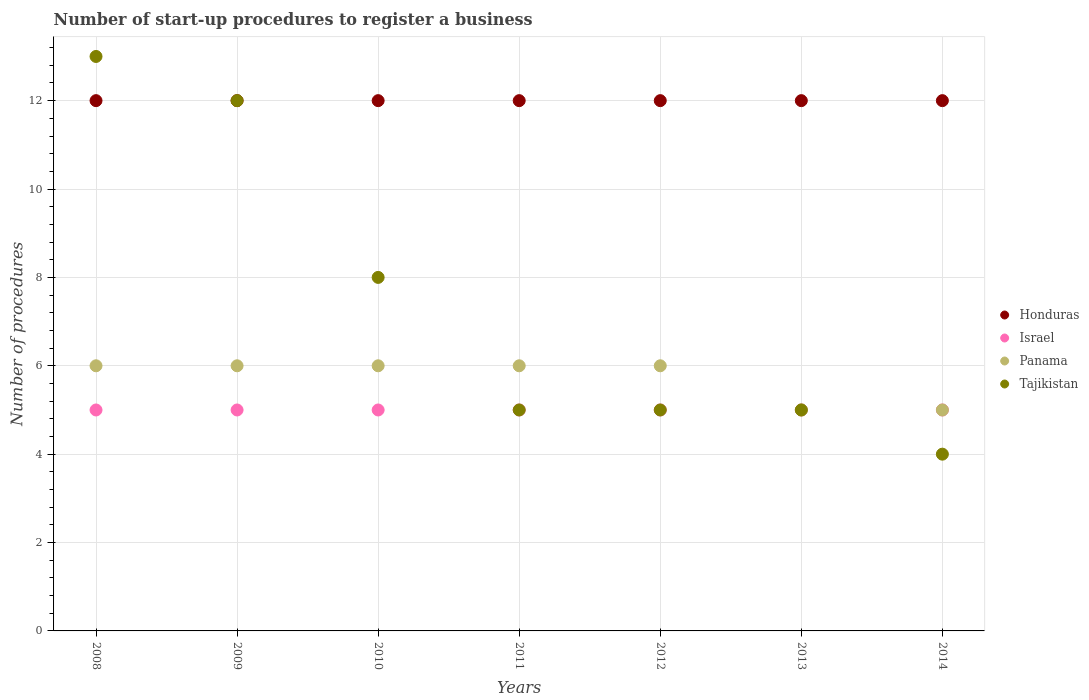Is the number of dotlines equal to the number of legend labels?
Provide a short and direct response. Yes. What is the number of procedures required to register a business in Israel in 2012?
Your answer should be very brief. 5. Across all years, what is the maximum number of procedures required to register a business in Panama?
Ensure brevity in your answer.  6. Across all years, what is the minimum number of procedures required to register a business in Panama?
Your response must be concise. 5. In which year was the number of procedures required to register a business in Tajikistan maximum?
Provide a succinct answer. 2008. In which year was the number of procedures required to register a business in Tajikistan minimum?
Ensure brevity in your answer.  2014. What is the total number of procedures required to register a business in Israel in the graph?
Ensure brevity in your answer.  35. What is the difference between the number of procedures required to register a business in Tajikistan in 2011 and the number of procedures required to register a business in Israel in 2013?
Offer a terse response. 0. What is the average number of procedures required to register a business in Tajikistan per year?
Give a very brief answer. 7.43. In the year 2008, what is the difference between the number of procedures required to register a business in Honduras and number of procedures required to register a business in Israel?
Keep it short and to the point. 7. In how many years, is the number of procedures required to register a business in Tajikistan greater than 12.4?
Your response must be concise. 1. What is the ratio of the number of procedures required to register a business in Panama in 2008 to that in 2012?
Your answer should be compact. 1. Is the number of procedures required to register a business in Panama in 2010 less than that in 2011?
Ensure brevity in your answer.  No. Is the difference between the number of procedures required to register a business in Honduras in 2013 and 2014 greater than the difference between the number of procedures required to register a business in Israel in 2013 and 2014?
Your answer should be very brief. No. What is the difference between the highest and the lowest number of procedures required to register a business in Tajikistan?
Give a very brief answer. 9. Is the sum of the number of procedures required to register a business in Panama in 2012 and 2014 greater than the maximum number of procedures required to register a business in Tajikistan across all years?
Keep it short and to the point. No. Is it the case that in every year, the sum of the number of procedures required to register a business in Tajikistan and number of procedures required to register a business in Panama  is greater than the sum of number of procedures required to register a business in Honduras and number of procedures required to register a business in Israel?
Your answer should be very brief. No. Does the number of procedures required to register a business in Honduras monotonically increase over the years?
Offer a very short reply. No. Is the number of procedures required to register a business in Panama strictly greater than the number of procedures required to register a business in Israel over the years?
Ensure brevity in your answer.  No. How many dotlines are there?
Make the answer very short. 4. What is the difference between two consecutive major ticks on the Y-axis?
Ensure brevity in your answer.  2. Are the values on the major ticks of Y-axis written in scientific E-notation?
Offer a very short reply. No. Does the graph contain grids?
Offer a terse response. Yes. How are the legend labels stacked?
Provide a short and direct response. Vertical. What is the title of the graph?
Provide a succinct answer. Number of start-up procedures to register a business. Does "World" appear as one of the legend labels in the graph?
Your response must be concise. No. What is the label or title of the Y-axis?
Offer a terse response. Number of procedures. What is the Number of procedures of Honduras in 2008?
Give a very brief answer. 12. What is the Number of procedures of Israel in 2008?
Provide a short and direct response. 5. What is the Number of procedures of Panama in 2008?
Offer a terse response. 6. What is the Number of procedures in Tajikistan in 2008?
Give a very brief answer. 13. What is the Number of procedures of Israel in 2009?
Offer a terse response. 5. What is the Number of procedures of Panama in 2009?
Give a very brief answer. 6. What is the Number of procedures of Panama in 2010?
Your answer should be very brief. 6. What is the Number of procedures of Honduras in 2011?
Ensure brevity in your answer.  12. What is the Number of procedures of Tajikistan in 2011?
Keep it short and to the point. 5. What is the Number of procedures of Honduras in 2012?
Make the answer very short. 12. What is the Number of procedures in Israel in 2012?
Provide a succinct answer. 5. What is the Number of procedures of Panama in 2012?
Provide a short and direct response. 6. What is the Number of procedures in Tajikistan in 2012?
Provide a succinct answer. 5. What is the Number of procedures of Honduras in 2013?
Ensure brevity in your answer.  12. What is the Number of procedures of Panama in 2013?
Your response must be concise. 5. What is the Number of procedures in Honduras in 2014?
Offer a terse response. 12. What is the Number of procedures in Israel in 2014?
Offer a very short reply. 5. What is the Number of procedures of Panama in 2014?
Ensure brevity in your answer.  5. Across all years, what is the maximum Number of procedures in Israel?
Make the answer very short. 5. Across all years, what is the maximum Number of procedures of Panama?
Your response must be concise. 6. Across all years, what is the maximum Number of procedures in Tajikistan?
Ensure brevity in your answer.  13. Across all years, what is the minimum Number of procedures of Israel?
Your answer should be very brief. 5. What is the total Number of procedures of Honduras in the graph?
Your answer should be compact. 84. What is the total Number of procedures in Israel in the graph?
Keep it short and to the point. 35. What is the difference between the Number of procedures of Panama in 2008 and that in 2009?
Give a very brief answer. 0. What is the difference between the Number of procedures of Panama in 2008 and that in 2010?
Offer a very short reply. 0. What is the difference between the Number of procedures in Panama in 2008 and that in 2011?
Provide a short and direct response. 0. What is the difference between the Number of procedures of Honduras in 2008 and that in 2012?
Provide a succinct answer. 0. What is the difference between the Number of procedures of Panama in 2008 and that in 2012?
Ensure brevity in your answer.  0. What is the difference between the Number of procedures of Tajikistan in 2008 and that in 2012?
Ensure brevity in your answer.  8. What is the difference between the Number of procedures of Israel in 2008 and that in 2013?
Ensure brevity in your answer.  0. What is the difference between the Number of procedures of Panama in 2008 and that in 2013?
Your response must be concise. 1. What is the difference between the Number of procedures in Tajikistan in 2008 and that in 2013?
Provide a short and direct response. 8. What is the difference between the Number of procedures of Honduras in 2008 and that in 2014?
Give a very brief answer. 0. What is the difference between the Number of procedures of Tajikistan in 2008 and that in 2014?
Provide a succinct answer. 9. What is the difference between the Number of procedures in Honduras in 2009 and that in 2010?
Offer a terse response. 0. What is the difference between the Number of procedures of Israel in 2009 and that in 2010?
Your response must be concise. 0. What is the difference between the Number of procedures of Tajikistan in 2009 and that in 2010?
Your response must be concise. 4. What is the difference between the Number of procedures of Honduras in 2009 and that in 2011?
Ensure brevity in your answer.  0. What is the difference between the Number of procedures in Honduras in 2009 and that in 2012?
Provide a short and direct response. 0. What is the difference between the Number of procedures in Israel in 2009 and that in 2012?
Offer a very short reply. 0. What is the difference between the Number of procedures in Panama in 2009 and that in 2012?
Give a very brief answer. 0. What is the difference between the Number of procedures of Honduras in 2009 and that in 2014?
Provide a short and direct response. 0. What is the difference between the Number of procedures of Israel in 2009 and that in 2014?
Offer a very short reply. 0. What is the difference between the Number of procedures in Tajikistan in 2009 and that in 2014?
Make the answer very short. 8. What is the difference between the Number of procedures of Honduras in 2010 and that in 2011?
Give a very brief answer. 0. What is the difference between the Number of procedures of Panama in 2010 and that in 2011?
Your response must be concise. 0. What is the difference between the Number of procedures in Israel in 2010 and that in 2012?
Your response must be concise. 0. What is the difference between the Number of procedures in Tajikistan in 2010 and that in 2013?
Give a very brief answer. 3. What is the difference between the Number of procedures in Honduras in 2010 and that in 2014?
Your answer should be compact. 0. What is the difference between the Number of procedures of Israel in 2010 and that in 2014?
Provide a succinct answer. 0. What is the difference between the Number of procedures of Panama in 2010 and that in 2014?
Give a very brief answer. 1. What is the difference between the Number of procedures in Tajikistan in 2010 and that in 2014?
Offer a very short reply. 4. What is the difference between the Number of procedures in Israel in 2011 and that in 2012?
Make the answer very short. 0. What is the difference between the Number of procedures in Honduras in 2011 and that in 2013?
Offer a terse response. 0. What is the difference between the Number of procedures in Israel in 2011 and that in 2013?
Offer a very short reply. 0. What is the difference between the Number of procedures of Panama in 2011 and that in 2013?
Make the answer very short. 1. What is the difference between the Number of procedures in Tajikistan in 2011 and that in 2014?
Your answer should be very brief. 1. What is the difference between the Number of procedures in Honduras in 2012 and that in 2014?
Give a very brief answer. 0. What is the difference between the Number of procedures in Israel in 2012 and that in 2014?
Offer a terse response. 0. What is the difference between the Number of procedures of Panama in 2012 and that in 2014?
Your answer should be compact. 1. What is the difference between the Number of procedures of Honduras in 2013 and that in 2014?
Your answer should be compact. 0. What is the difference between the Number of procedures of Tajikistan in 2013 and that in 2014?
Give a very brief answer. 1. What is the difference between the Number of procedures of Honduras in 2008 and the Number of procedures of Panama in 2009?
Make the answer very short. 6. What is the difference between the Number of procedures in Honduras in 2008 and the Number of procedures in Tajikistan in 2009?
Keep it short and to the point. 0. What is the difference between the Number of procedures in Israel in 2008 and the Number of procedures in Panama in 2009?
Ensure brevity in your answer.  -1. What is the difference between the Number of procedures in Israel in 2008 and the Number of procedures in Tajikistan in 2009?
Make the answer very short. -7. What is the difference between the Number of procedures in Panama in 2008 and the Number of procedures in Tajikistan in 2009?
Offer a very short reply. -6. What is the difference between the Number of procedures in Honduras in 2008 and the Number of procedures in Tajikistan in 2010?
Make the answer very short. 4. What is the difference between the Number of procedures of Israel in 2008 and the Number of procedures of Panama in 2010?
Your answer should be very brief. -1. What is the difference between the Number of procedures in Israel in 2008 and the Number of procedures in Tajikistan in 2010?
Your answer should be compact. -3. What is the difference between the Number of procedures in Panama in 2008 and the Number of procedures in Tajikistan in 2010?
Provide a short and direct response. -2. What is the difference between the Number of procedures of Honduras in 2008 and the Number of procedures of Israel in 2011?
Give a very brief answer. 7. What is the difference between the Number of procedures of Honduras in 2008 and the Number of procedures of Panama in 2011?
Your answer should be very brief. 6. What is the difference between the Number of procedures in Israel in 2008 and the Number of procedures in Panama in 2011?
Make the answer very short. -1. What is the difference between the Number of procedures in Israel in 2008 and the Number of procedures in Tajikistan in 2011?
Provide a short and direct response. 0. What is the difference between the Number of procedures of Panama in 2008 and the Number of procedures of Tajikistan in 2011?
Your response must be concise. 1. What is the difference between the Number of procedures of Honduras in 2008 and the Number of procedures of Israel in 2012?
Offer a terse response. 7. What is the difference between the Number of procedures of Honduras in 2008 and the Number of procedures of Panama in 2012?
Keep it short and to the point. 6. What is the difference between the Number of procedures in Honduras in 2008 and the Number of procedures in Panama in 2013?
Keep it short and to the point. 7. What is the difference between the Number of procedures in Honduras in 2008 and the Number of procedures in Tajikistan in 2013?
Your response must be concise. 7. What is the difference between the Number of procedures in Israel in 2008 and the Number of procedures in Panama in 2013?
Your response must be concise. 0. What is the difference between the Number of procedures of Honduras in 2008 and the Number of procedures of Panama in 2014?
Ensure brevity in your answer.  7. What is the difference between the Number of procedures of Panama in 2008 and the Number of procedures of Tajikistan in 2014?
Offer a terse response. 2. What is the difference between the Number of procedures in Honduras in 2009 and the Number of procedures in Panama in 2010?
Offer a very short reply. 6. What is the difference between the Number of procedures in Israel in 2009 and the Number of procedures in Panama in 2010?
Make the answer very short. -1. What is the difference between the Number of procedures in Israel in 2009 and the Number of procedures in Tajikistan in 2010?
Offer a terse response. -3. What is the difference between the Number of procedures in Panama in 2009 and the Number of procedures in Tajikistan in 2010?
Keep it short and to the point. -2. What is the difference between the Number of procedures in Honduras in 2009 and the Number of procedures in Israel in 2011?
Provide a succinct answer. 7. What is the difference between the Number of procedures in Honduras in 2009 and the Number of procedures in Panama in 2011?
Give a very brief answer. 6. What is the difference between the Number of procedures in Honduras in 2009 and the Number of procedures in Tajikistan in 2011?
Provide a short and direct response. 7. What is the difference between the Number of procedures in Israel in 2009 and the Number of procedures in Tajikistan in 2011?
Offer a terse response. 0. What is the difference between the Number of procedures in Israel in 2009 and the Number of procedures in Tajikistan in 2012?
Provide a succinct answer. 0. What is the difference between the Number of procedures of Israel in 2009 and the Number of procedures of Panama in 2013?
Provide a short and direct response. 0. What is the difference between the Number of procedures in Israel in 2009 and the Number of procedures in Tajikistan in 2013?
Offer a terse response. 0. What is the difference between the Number of procedures of Panama in 2009 and the Number of procedures of Tajikistan in 2013?
Give a very brief answer. 1. What is the difference between the Number of procedures in Honduras in 2009 and the Number of procedures in Panama in 2014?
Offer a very short reply. 7. What is the difference between the Number of procedures of Honduras in 2009 and the Number of procedures of Tajikistan in 2014?
Offer a terse response. 8. What is the difference between the Number of procedures of Israel in 2009 and the Number of procedures of Tajikistan in 2014?
Ensure brevity in your answer.  1. What is the difference between the Number of procedures of Honduras in 2010 and the Number of procedures of Israel in 2011?
Offer a very short reply. 7. What is the difference between the Number of procedures of Israel in 2010 and the Number of procedures of Tajikistan in 2011?
Your answer should be very brief. 0. What is the difference between the Number of procedures in Honduras in 2010 and the Number of procedures in Tajikistan in 2012?
Offer a very short reply. 7. What is the difference between the Number of procedures in Israel in 2010 and the Number of procedures in Tajikistan in 2012?
Offer a terse response. 0. What is the difference between the Number of procedures in Honduras in 2010 and the Number of procedures in Panama in 2013?
Provide a short and direct response. 7. What is the difference between the Number of procedures in Honduras in 2010 and the Number of procedures in Tajikistan in 2013?
Keep it short and to the point. 7. What is the difference between the Number of procedures of Israel in 2010 and the Number of procedures of Panama in 2013?
Your response must be concise. 0. What is the difference between the Number of procedures in Honduras in 2010 and the Number of procedures in Israel in 2014?
Give a very brief answer. 7. What is the difference between the Number of procedures in Panama in 2010 and the Number of procedures in Tajikistan in 2014?
Provide a short and direct response. 2. What is the difference between the Number of procedures of Honduras in 2011 and the Number of procedures of Israel in 2012?
Offer a very short reply. 7. What is the difference between the Number of procedures of Israel in 2011 and the Number of procedures of Panama in 2012?
Offer a terse response. -1. What is the difference between the Number of procedures in Honduras in 2011 and the Number of procedures in Israel in 2013?
Provide a short and direct response. 7. What is the difference between the Number of procedures in Honduras in 2011 and the Number of procedures in Panama in 2013?
Your answer should be very brief. 7. What is the difference between the Number of procedures of Panama in 2011 and the Number of procedures of Tajikistan in 2013?
Your answer should be very brief. 1. What is the difference between the Number of procedures of Honduras in 2011 and the Number of procedures of Panama in 2014?
Keep it short and to the point. 7. What is the difference between the Number of procedures in Panama in 2011 and the Number of procedures in Tajikistan in 2014?
Your response must be concise. 2. What is the difference between the Number of procedures of Honduras in 2012 and the Number of procedures of Israel in 2013?
Provide a succinct answer. 7. What is the difference between the Number of procedures in Honduras in 2012 and the Number of procedures in Panama in 2013?
Your response must be concise. 7. What is the difference between the Number of procedures in Honduras in 2012 and the Number of procedures in Tajikistan in 2013?
Make the answer very short. 7. What is the difference between the Number of procedures of Israel in 2012 and the Number of procedures of Panama in 2013?
Your response must be concise. 0. What is the difference between the Number of procedures of Panama in 2012 and the Number of procedures of Tajikistan in 2013?
Provide a short and direct response. 1. What is the difference between the Number of procedures in Honduras in 2012 and the Number of procedures in Israel in 2014?
Your answer should be very brief. 7. What is the difference between the Number of procedures in Honduras in 2012 and the Number of procedures in Tajikistan in 2014?
Your answer should be compact. 8. What is the difference between the Number of procedures of Panama in 2012 and the Number of procedures of Tajikistan in 2014?
Give a very brief answer. 2. What is the difference between the Number of procedures of Israel in 2013 and the Number of procedures of Panama in 2014?
Provide a succinct answer. 0. What is the difference between the Number of procedures of Panama in 2013 and the Number of procedures of Tajikistan in 2014?
Give a very brief answer. 1. What is the average Number of procedures in Honduras per year?
Provide a succinct answer. 12. What is the average Number of procedures in Israel per year?
Your response must be concise. 5. What is the average Number of procedures in Panama per year?
Provide a succinct answer. 5.71. What is the average Number of procedures in Tajikistan per year?
Your answer should be compact. 7.43. In the year 2008, what is the difference between the Number of procedures in Honduras and Number of procedures in Israel?
Make the answer very short. 7. In the year 2008, what is the difference between the Number of procedures of Honduras and Number of procedures of Panama?
Make the answer very short. 6. In the year 2008, what is the difference between the Number of procedures of Israel and Number of procedures of Tajikistan?
Provide a short and direct response. -8. In the year 2008, what is the difference between the Number of procedures of Panama and Number of procedures of Tajikistan?
Your response must be concise. -7. In the year 2009, what is the difference between the Number of procedures of Honduras and Number of procedures of Israel?
Give a very brief answer. 7. In the year 2009, what is the difference between the Number of procedures in Honduras and Number of procedures in Panama?
Keep it short and to the point. 6. In the year 2009, what is the difference between the Number of procedures of Honduras and Number of procedures of Tajikistan?
Ensure brevity in your answer.  0. In the year 2010, what is the difference between the Number of procedures of Honduras and Number of procedures of Tajikistan?
Offer a very short reply. 4. In the year 2011, what is the difference between the Number of procedures in Honduras and Number of procedures in Israel?
Your response must be concise. 7. In the year 2011, what is the difference between the Number of procedures in Panama and Number of procedures in Tajikistan?
Give a very brief answer. 1. In the year 2012, what is the difference between the Number of procedures in Honduras and Number of procedures in Panama?
Make the answer very short. 6. In the year 2012, what is the difference between the Number of procedures in Honduras and Number of procedures in Tajikistan?
Provide a succinct answer. 7. In the year 2012, what is the difference between the Number of procedures of Israel and Number of procedures of Panama?
Provide a succinct answer. -1. In the year 2013, what is the difference between the Number of procedures in Honduras and Number of procedures in Tajikistan?
Ensure brevity in your answer.  7. In the year 2013, what is the difference between the Number of procedures in Panama and Number of procedures in Tajikistan?
Give a very brief answer. 0. In the year 2014, what is the difference between the Number of procedures in Honduras and Number of procedures in Tajikistan?
Your answer should be compact. 8. In the year 2014, what is the difference between the Number of procedures in Israel and Number of procedures in Tajikistan?
Your answer should be very brief. 1. In the year 2014, what is the difference between the Number of procedures in Panama and Number of procedures in Tajikistan?
Your response must be concise. 1. What is the ratio of the Number of procedures of Honduras in 2008 to that in 2009?
Your response must be concise. 1. What is the ratio of the Number of procedures of Panama in 2008 to that in 2009?
Ensure brevity in your answer.  1. What is the ratio of the Number of procedures of Honduras in 2008 to that in 2010?
Give a very brief answer. 1. What is the ratio of the Number of procedures in Israel in 2008 to that in 2010?
Offer a terse response. 1. What is the ratio of the Number of procedures in Panama in 2008 to that in 2010?
Offer a terse response. 1. What is the ratio of the Number of procedures of Tajikistan in 2008 to that in 2010?
Your response must be concise. 1.62. What is the ratio of the Number of procedures of Honduras in 2008 to that in 2011?
Offer a terse response. 1. What is the ratio of the Number of procedures of Panama in 2008 to that in 2011?
Your response must be concise. 1. What is the ratio of the Number of procedures in Tajikistan in 2008 to that in 2011?
Provide a short and direct response. 2.6. What is the ratio of the Number of procedures of Israel in 2008 to that in 2012?
Offer a very short reply. 1. What is the ratio of the Number of procedures in Israel in 2008 to that in 2013?
Your response must be concise. 1. What is the ratio of the Number of procedures of Panama in 2008 to that in 2013?
Keep it short and to the point. 1.2. What is the ratio of the Number of procedures of Tajikistan in 2008 to that in 2013?
Offer a terse response. 2.6. What is the ratio of the Number of procedures of Israel in 2008 to that in 2014?
Offer a terse response. 1. What is the ratio of the Number of procedures of Panama in 2008 to that in 2014?
Keep it short and to the point. 1.2. What is the ratio of the Number of procedures in Israel in 2009 to that in 2011?
Provide a succinct answer. 1. What is the ratio of the Number of procedures of Tajikistan in 2009 to that in 2011?
Offer a very short reply. 2.4. What is the ratio of the Number of procedures in Tajikistan in 2009 to that in 2012?
Make the answer very short. 2.4. What is the ratio of the Number of procedures in Honduras in 2009 to that in 2013?
Offer a very short reply. 1. What is the ratio of the Number of procedures in Panama in 2009 to that in 2013?
Offer a very short reply. 1.2. What is the ratio of the Number of procedures in Tajikistan in 2009 to that in 2013?
Make the answer very short. 2.4. What is the ratio of the Number of procedures of Honduras in 2009 to that in 2014?
Provide a short and direct response. 1. What is the ratio of the Number of procedures of Panama in 2009 to that in 2014?
Make the answer very short. 1.2. What is the ratio of the Number of procedures of Tajikistan in 2010 to that in 2011?
Offer a very short reply. 1.6. What is the ratio of the Number of procedures of Honduras in 2010 to that in 2012?
Make the answer very short. 1. What is the ratio of the Number of procedures in Israel in 2010 to that in 2012?
Ensure brevity in your answer.  1. What is the ratio of the Number of procedures of Panama in 2010 to that in 2012?
Give a very brief answer. 1. What is the ratio of the Number of procedures of Tajikistan in 2010 to that in 2012?
Provide a short and direct response. 1.6. What is the ratio of the Number of procedures in Honduras in 2010 to that in 2013?
Make the answer very short. 1. What is the ratio of the Number of procedures of Israel in 2010 to that in 2013?
Ensure brevity in your answer.  1. What is the ratio of the Number of procedures in Panama in 2010 to that in 2013?
Make the answer very short. 1.2. What is the ratio of the Number of procedures in Tajikistan in 2010 to that in 2013?
Your answer should be very brief. 1.6. What is the ratio of the Number of procedures of Panama in 2011 to that in 2012?
Your answer should be very brief. 1. What is the ratio of the Number of procedures of Tajikistan in 2011 to that in 2012?
Your response must be concise. 1. What is the ratio of the Number of procedures of Tajikistan in 2011 to that in 2013?
Your response must be concise. 1. What is the ratio of the Number of procedures of Honduras in 2011 to that in 2014?
Keep it short and to the point. 1. What is the ratio of the Number of procedures of Panama in 2011 to that in 2014?
Offer a very short reply. 1.2. What is the ratio of the Number of procedures of Tajikistan in 2011 to that in 2014?
Your answer should be compact. 1.25. What is the ratio of the Number of procedures of Israel in 2012 to that in 2013?
Keep it short and to the point. 1. What is the ratio of the Number of procedures of Israel in 2012 to that in 2014?
Keep it short and to the point. 1. What is the ratio of the Number of procedures in Panama in 2012 to that in 2014?
Your response must be concise. 1.2. What is the ratio of the Number of procedures of Tajikistan in 2012 to that in 2014?
Keep it short and to the point. 1.25. What is the ratio of the Number of procedures in Honduras in 2013 to that in 2014?
Offer a very short reply. 1. What is the ratio of the Number of procedures in Israel in 2013 to that in 2014?
Offer a very short reply. 1. What is the difference between the highest and the second highest Number of procedures of Israel?
Your answer should be very brief. 0. What is the difference between the highest and the second highest Number of procedures in Tajikistan?
Your response must be concise. 1. What is the difference between the highest and the lowest Number of procedures of Honduras?
Offer a very short reply. 0. What is the difference between the highest and the lowest Number of procedures in Israel?
Keep it short and to the point. 0. What is the difference between the highest and the lowest Number of procedures in Panama?
Offer a terse response. 1. What is the difference between the highest and the lowest Number of procedures in Tajikistan?
Make the answer very short. 9. 